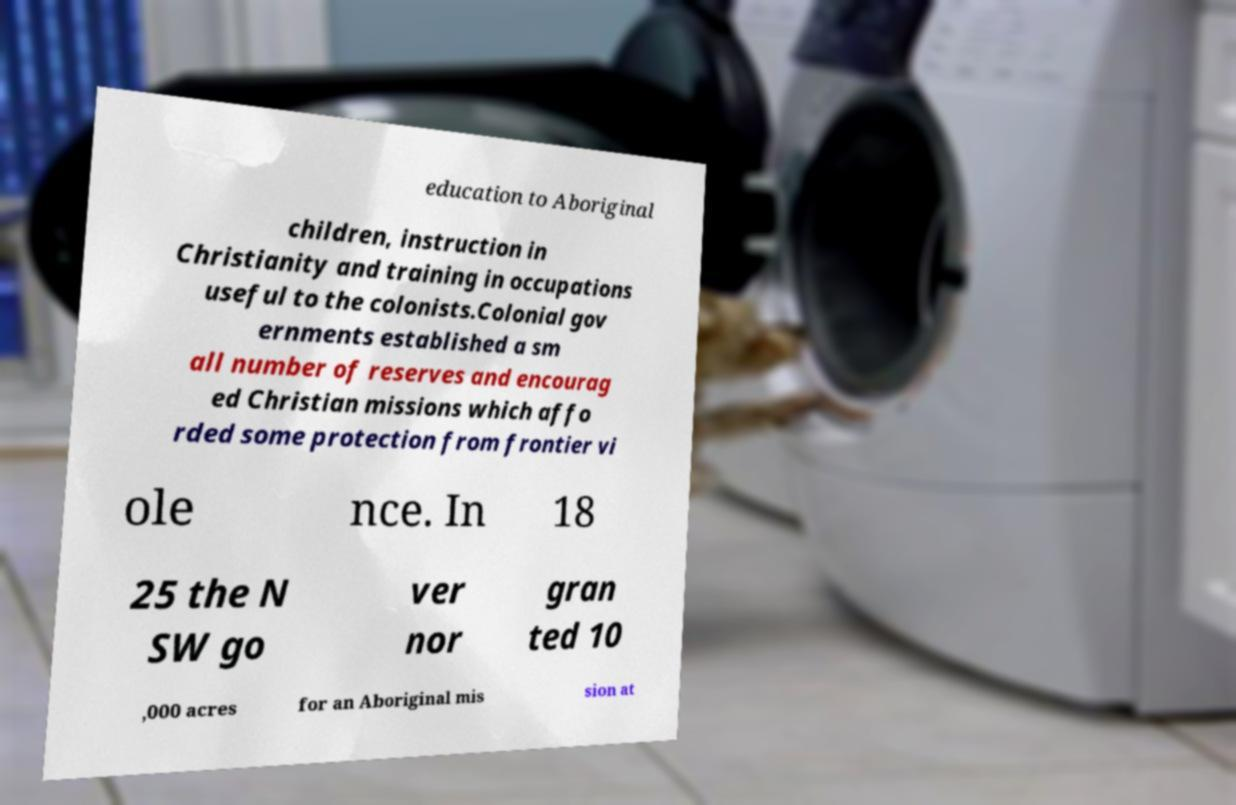I need the written content from this picture converted into text. Can you do that? education to Aboriginal children, instruction in Christianity and training in occupations useful to the colonists.Colonial gov ernments established a sm all number of reserves and encourag ed Christian missions which affo rded some protection from frontier vi ole nce. In 18 25 the N SW go ver nor gran ted 10 ,000 acres for an Aboriginal mis sion at 